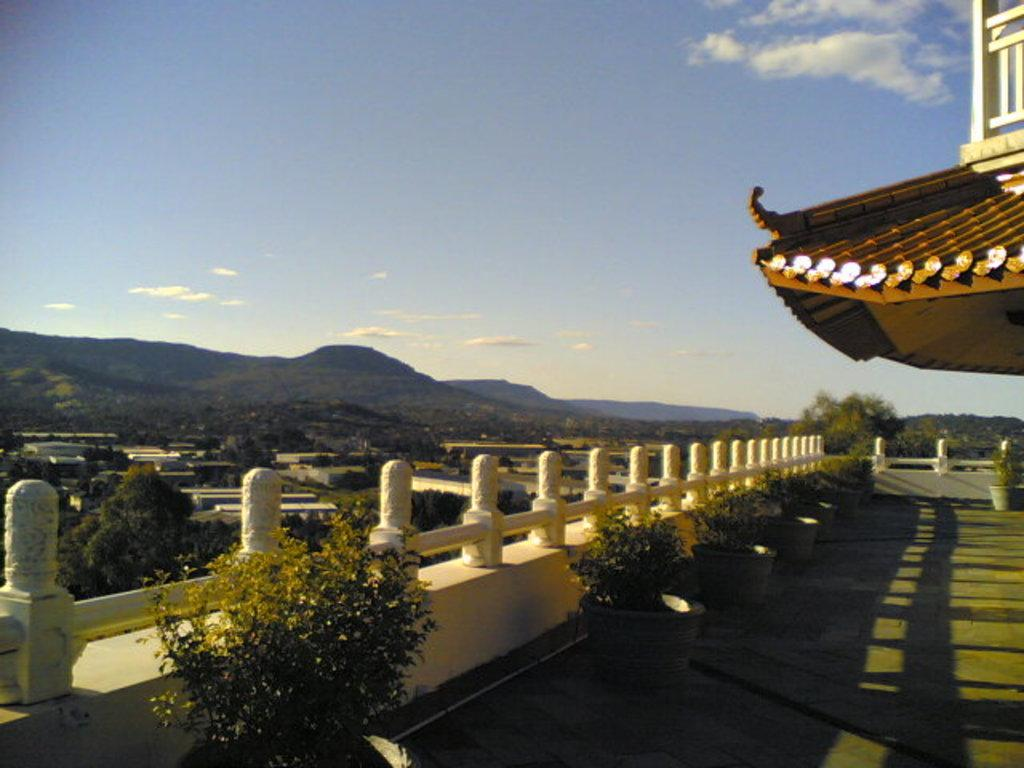What structure is visible above the balcony in the image? There is a roof in the image. What is located under the roof? There is a balcony under the roof. What can be seen on the balcony? There are small plants on the balcony. What is visible in the background of the image? There are trees and mountains in the background of the image. Where is the toothbrush placed in the image? There is no toothbrush present in the image. What type of lunch is being served on the balcony? There is no lunch visible in the image; only small plants are present on the balcony. 